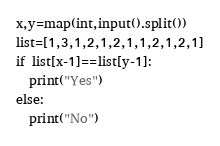<code> <loc_0><loc_0><loc_500><loc_500><_Python_>x,y=map(int,input().split())
list=[1,3,1,2,1,2,1,1,2,1,2,1]
if list[x-1]==list[y-1]:
  print("Yes")
else:
  print("No")</code> 